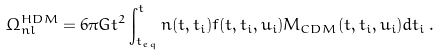Convert formula to latex. <formula><loc_0><loc_0><loc_500><loc_500>\Omega _ { n l } ^ { H D M } = 6 \pi G t ^ { 2 } \int _ { t _ { e q } } ^ { t } n ( t , t _ { i } ) f ( t , t _ { i } , u _ { i } ) M _ { C D M } ( t , t _ { i } , u _ { i } ) d t _ { i } \, .</formula> 